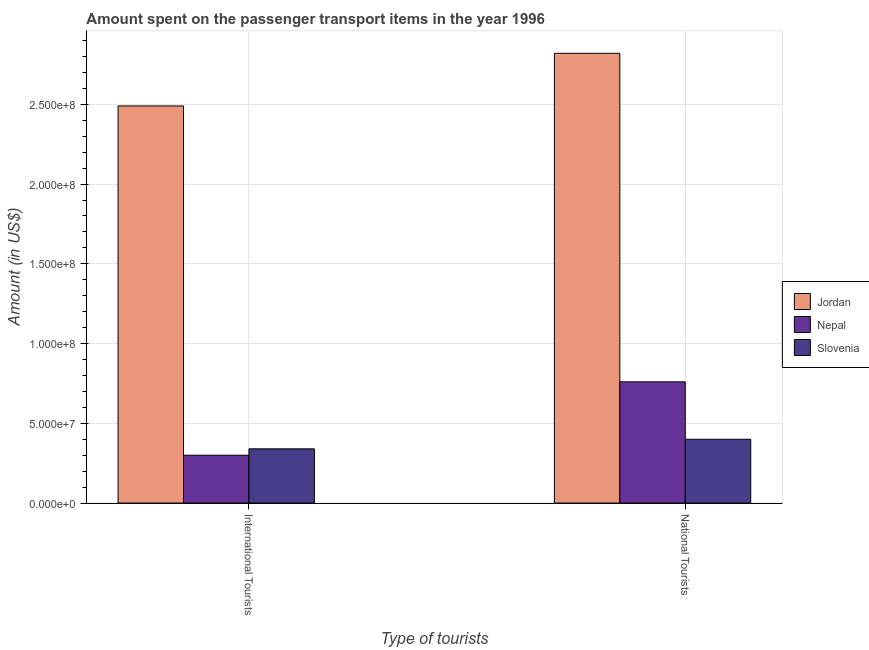How many different coloured bars are there?
Provide a short and direct response. 3. How many groups of bars are there?
Give a very brief answer. 2. Are the number of bars on each tick of the X-axis equal?
Offer a very short reply. Yes. How many bars are there on the 1st tick from the left?
Your answer should be compact. 3. How many bars are there on the 2nd tick from the right?
Your answer should be very brief. 3. What is the label of the 1st group of bars from the left?
Provide a short and direct response. International Tourists. What is the amount spent on transport items of national tourists in Nepal?
Your answer should be compact. 7.60e+07. Across all countries, what is the maximum amount spent on transport items of national tourists?
Your answer should be compact. 2.82e+08. Across all countries, what is the minimum amount spent on transport items of international tourists?
Your answer should be very brief. 3.00e+07. In which country was the amount spent on transport items of national tourists maximum?
Keep it short and to the point. Jordan. In which country was the amount spent on transport items of international tourists minimum?
Your response must be concise. Nepal. What is the total amount spent on transport items of national tourists in the graph?
Provide a short and direct response. 3.98e+08. What is the difference between the amount spent on transport items of international tourists in Nepal and that in Slovenia?
Ensure brevity in your answer.  -4.00e+06. What is the difference between the amount spent on transport items of national tourists in Jordan and the amount spent on transport items of international tourists in Nepal?
Provide a succinct answer. 2.52e+08. What is the average amount spent on transport items of national tourists per country?
Make the answer very short. 1.33e+08. What is the difference between the amount spent on transport items of national tourists and amount spent on transport items of international tourists in Nepal?
Ensure brevity in your answer.  4.60e+07. What is the ratio of the amount spent on transport items of international tourists in Nepal to that in Jordan?
Ensure brevity in your answer.  0.12. In how many countries, is the amount spent on transport items of national tourists greater than the average amount spent on transport items of national tourists taken over all countries?
Your answer should be very brief. 1. What does the 1st bar from the left in International Tourists represents?
Your answer should be very brief. Jordan. What does the 3rd bar from the right in National Tourists represents?
Ensure brevity in your answer.  Jordan. How many bars are there?
Give a very brief answer. 6. What is the difference between two consecutive major ticks on the Y-axis?
Give a very brief answer. 5.00e+07. Are the values on the major ticks of Y-axis written in scientific E-notation?
Give a very brief answer. Yes. Does the graph contain any zero values?
Your response must be concise. No. Where does the legend appear in the graph?
Provide a short and direct response. Center right. How many legend labels are there?
Your answer should be compact. 3. What is the title of the graph?
Keep it short and to the point. Amount spent on the passenger transport items in the year 1996. What is the label or title of the X-axis?
Offer a terse response. Type of tourists. What is the Amount (in US$) of Jordan in International Tourists?
Provide a short and direct response. 2.49e+08. What is the Amount (in US$) of Nepal in International Tourists?
Provide a succinct answer. 3.00e+07. What is the Amount (in US$) in Slovenia in International Tourists?
Offer a terse response. 3.40e+07. What is the Amount (in US$) in Jordan in National Tourists?
Make the answer very short. 2.82e+08. What is the Amount (in US$) in Nepal in National Tourists?
Ensure brevity in your answer.  7.60e+07. What is the Amount (in US$) of Slovenia in National Tourists?
Offer a terse response. 4.00e+07. Across all Type of tourists, what is the maximum Amount (in US$) in Jordan?
Provide a short and direct response. 2.82e+08. Across all Type of tourists, what is the maximum Amount (in US$) of Nepal?
Provide a succinct answer. 7.60e+07. Across all Type of tourists, what is the maximum Amount (in US$) of Slovenia?
Provide a succinct answer. 4.00e+07. Across all Type of tourists, what is the minimum Amount (in US$) of Jordan?
Provide a short and direct response. 2.49e+08. Across all Type of tourists, what is the minimum Amount (in US$) of Nepal?
Your answer should be very brief. 3.00e+07. Across all Type of tourists, what is the minimum Amount (in US$) of Slovenia?
Give a very brief answer. 3.40e+07. What is the total Amount (in US$) of Jordan in the graph?
Your answer should be compact. 5.31e+08. What is the total Amount (in US$) in Nepal in the graph?
Your answer should be compact. 1.06e+08. What is the total Amount (in US$) of Slovenia in the graph?
Ensure brevity in your answer.  7.40e+07. What is the difference between the Amount (in US$) in Jordan in International Tourists and that in National Tourists?
Make the answer very short. -3.30e+07. What is the difference between the Amount (in US$) of Nepal in International Tourists and that in National Tourists?
Offer a very short reply. -4.60e+07. What is the difference between the Amount (in US$) in Slovenia in International Tourists and that in National Tourists?
Your answer should be compact. -6.00e+06. What is the difference between the Amount (in US$) of Jordan in International Tourists and the Amount (in US$) of Nepal in National Tourists?
Your answer should be very brief. 1.73e+08. What is the difference between the Amount (in US$) of Jordan in International Tourists and the Amount (in US$) of Slovenia in National Tourists?
Your response must be concise. 2.09e+08. What is the difference between the Amount (in US$) in Nepal in International Tourists and the Amount (in US$) in Slovenia in National Tourists?
Your answer should be very brief. -1.00e+07. What is the average Amount (in US$) of Jordan per Type of tourists?
Offer a terse response. 2.66e+08. What is the average Amount (in US$) of Nepal per Type of tourists?
Provide a succinct answer. 5.30e+07. What is the average Amount (in US$) of Slovenia per Type of tourists?
Offer a terse response. 3.70e+07. What is the difference between the Amount (in US$) in Jordan and Amount (in US$) in Nepal in International Tourists?
Your answer should be very brief. 2.19e+08. What is the difference between the Amount (in US$) in Jordan and Amount (in US$) in Slovenia in International Tourists?
Your answer should be very brief. 2.15e+08. What is the difference between the Amount (in US$) of Jordan and Amount (in US$) of Nepal in National Tourists?
Provide a succinct answer. 2.06e+08. What is the difference between the Amount (in US$) in Jordan and Amount (in US$) in Slovenia in National Tourists?
Make the answer very short. 2.42e+08. What is the difference between the Amount (in US$) of Nepal and Amount (in US$) of Slovenia in National Tourists?
Your response must be concise. 3.60e+07. What is the ratio of the Amount (in US$) of Jordan in International Tourists to that in National Tourists?
Keep it short and to the point. 0.88. What is the ratio of the Amount (in US$) in Nepal in International Tourists to that in National Tourists?
Your answer should be compact. 0.39. What is the ratio of the Amount (in US$) of Slovenia in International Tourists to that in National Tourists?
Your response must be concise. 0.85. What is the difference between the highest and the second highest Amount (in US$) in Jordan?
Ensure brevity in your answer.  3.30e+07. What is the difference between the highest and the second highest Amount (in US$) in Nepal?
Provide a succinct answer. 4.60e+07. What is the difference between the highest and the lowest Amount (in US$) in Jordan?
Provide a short and direct response. 3.30e+07. What is the difference between the highest and the lowest Amount (in US$) of Nepal?
Your answer should be very brief. 4.60e+07. 